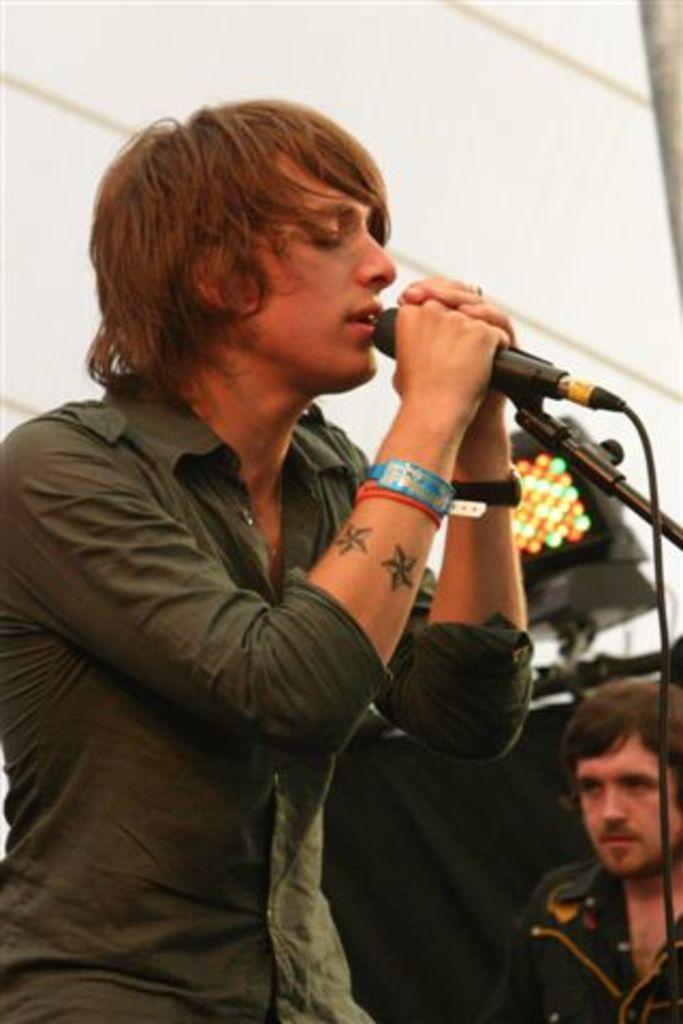Describe this image in one or two sentences. In this picture we can see a man holding a mike in his hand and singing. He wore watch and wristband. At the right side of the picture we can see other man. This is a light. 